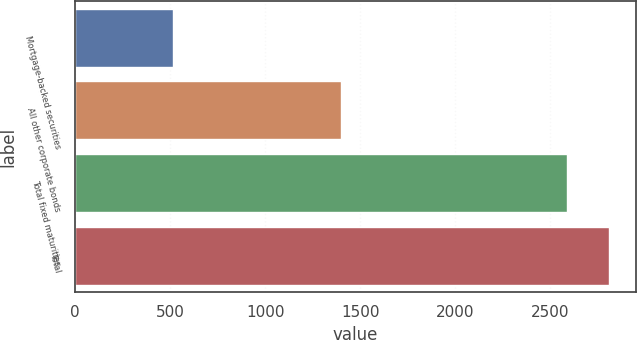Convert chart. <chart><loc_0><loc_0><loc_500><loc_500><bar_chart><fcel>Mortgage-backed securities<fcel>All other corporate bonds<fcel>Total fixed maturities<fcel>Total<nl><fcel>517<fcel>1400<fcel>2589<fcel>2807<nl></chart> 